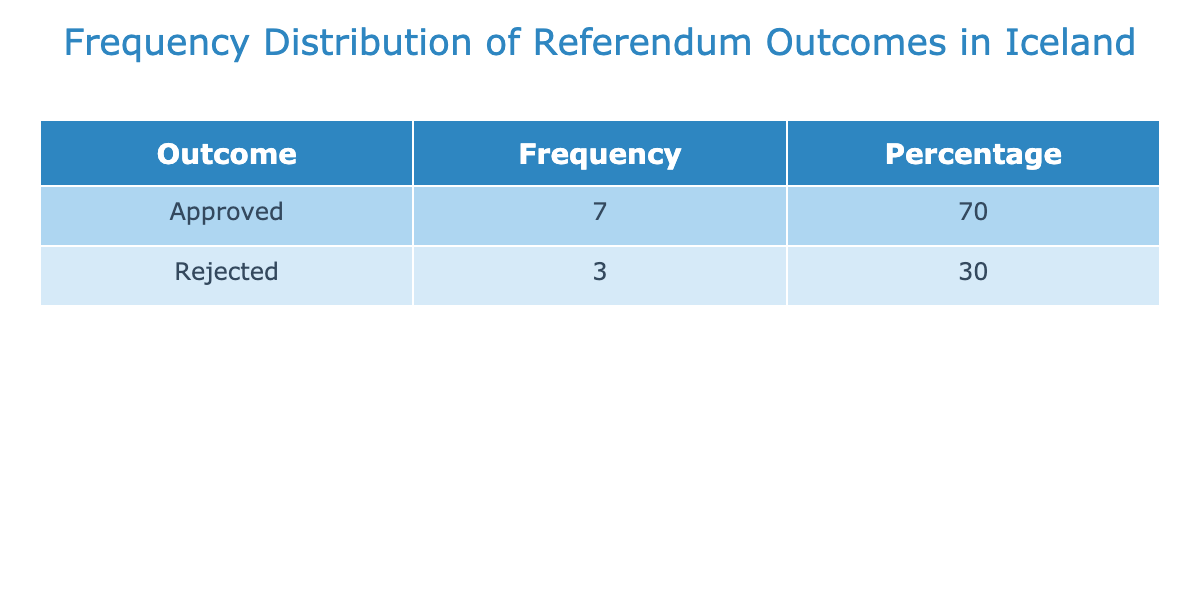What is the total number of referendums held in Iceland? There are 10 rows in the dataset, each representing a referendum held in Iceland's political history. Therefore, the total number of referendums is simply the count of these entries.
Answer: 10 How many referendums were approved? By counting the frequency of the "Approved" outcomes in the table, we find there are 6 referendums marked as approved.
Answer: 6 What percentage of referendums were rejected? There are 4 referendums that were rejected out of a total of 10. The percentage is calculated as (4/10) * 100 = 40%.
Answer: 40% Which referendum had the title "Referendum on the Icesave Settlement"? Referring to the table, we see that the "Referendum on the Icesave Settlement" took place in 2019 and was approved.
Answer: 2019, Approved Do more referendums have an approved outcome than a rejected one? There are 6 approved and 4 rejected referendums. Since 6 is greater than 4, the statement is true.
Answer: Yes What was the outcome of the first referendum held in Iceland? The first referendum listed is from 1944, titled "Constitutional Referendum for Independence," and it was approved.
Answer: Approved What is the difference in frequency between approved and rejected outcomes? Approved outcomes total 6, while rejected outcomes total 4. The difference is calculated as 6 - 4 = 2.
Answer: 2 How many referendums took place after the year 2000? By checking the years listed, there are 4 referendums that occurred after 2000: in 2010, 2012, and 2019.
Answer: 4 Was there ever a rejected constitutional referendum in Iceland? Looking at the table, there are two rejected constitutional referendums in 1974 and 2000, which confirms the statement is true.
Answer: Yes 